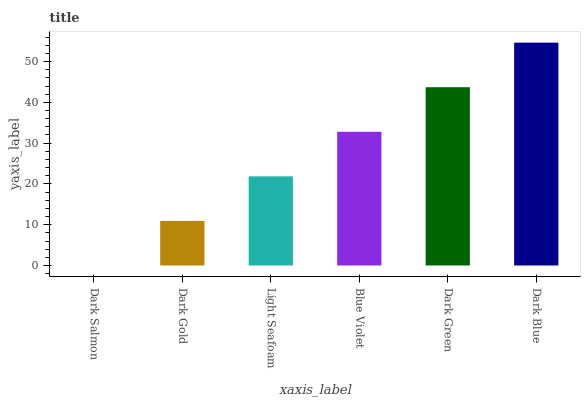Is Dark Salmon the minimum?
Answer yes or no. Yes. Is Dark Blue the maximum?
Answer yes or no. Yes. Is Dark Gold the minimum?
Answer yes or no. No. Is Dark Gold the maximum?
Answer yes or no. No. Is Dark Gold greater than Dark Salmon?
Answer yes or no. Yes. Is Dark Salmon less than Dark Gold?
Answer yes or no. Yes. Is Dark Salmon greater than Dark Gold?
Answer yes or no. No. Is Dark Gold less than Dark Salmon?
Answer yes or no. No. Is Blue Violet the high median?
Answer yes or no. Yes. Is Light Seafoam the low median?
Answer yes or no. Yes. Is Dark Green the high median?
Answer yes or no. No. Is Dark Blue the low median?
Answer yes or no. No. 